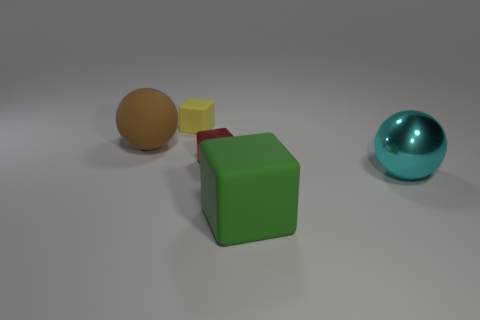What might be the context or purpose of this arrangement of objects? The objects might be arranged for a variety of purposes. It could be a simple artistic composition intended to explore color contrast, texture differences, and spatial relationships. Alternatively, it might be a setup for an educational demonstration about geometry, materials, and color theory. The stark differences among the objects provide an opportunity to discuss these concepts in depth. How could the different materials of the objects affect their utility or symbolism? The materials of the objects—matte finished cubes and sphere, and a shiny metallic sphere—could convey different meanings or serve different purposes. For instance, the reflective property of the shiny metallic sphere might symbolize ideas of clarity or futurism, while the matte finished objects could represent traditional or natural elements due to their subdued appearance. From a utility perspective, the material's texture could affect how each object is used or interacts with light, emphasizing different aspects of each object's geometry. 